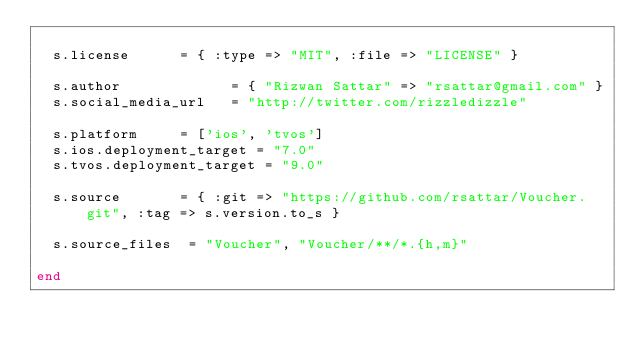<code> <loc_0><loc_0><loc_500><loc_500><_Ruby_>
  s.license      = { :type => "MIT", :file => "LICENSE" }

  s.author             = { "Rizwan Sattar" => "rsattar@gmail.com" }
  s.social_media_url   = "http://twitter.com/rizzledizzle"

  s.platform     = ['ios', 'tvos']
  s.ios.deployment_target = "7.0"
  s.tvos.deployment_target = "9.0"

  s.source       = { :git => "https://github.com/rsattar/Voucher.git", :tag => s.version.to_s }

  s.source_files  = "Voucher", "Voucher/**/*.{h,m}"

end
</code> 